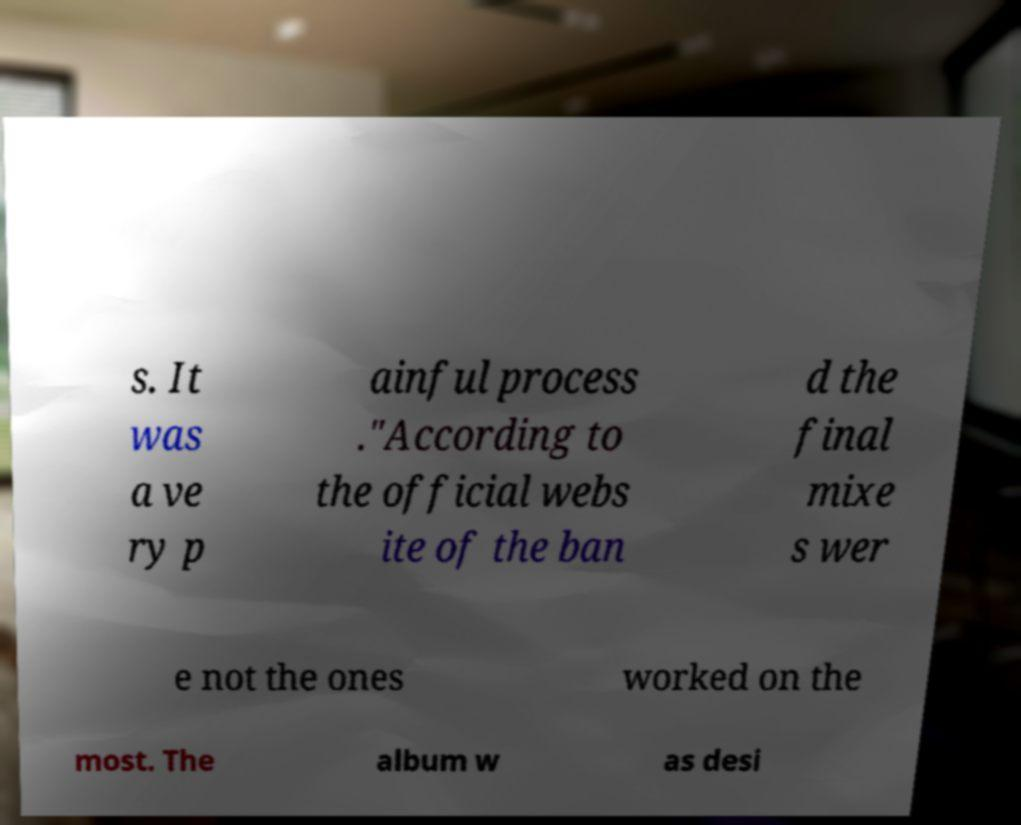I need the written content from this picture converted into text. Can you do that? s. It was a ve ry p ainful process ."According to the official webs ite of the ban d the final mixe s wer e not the ones worked on the most. The album w as desi 